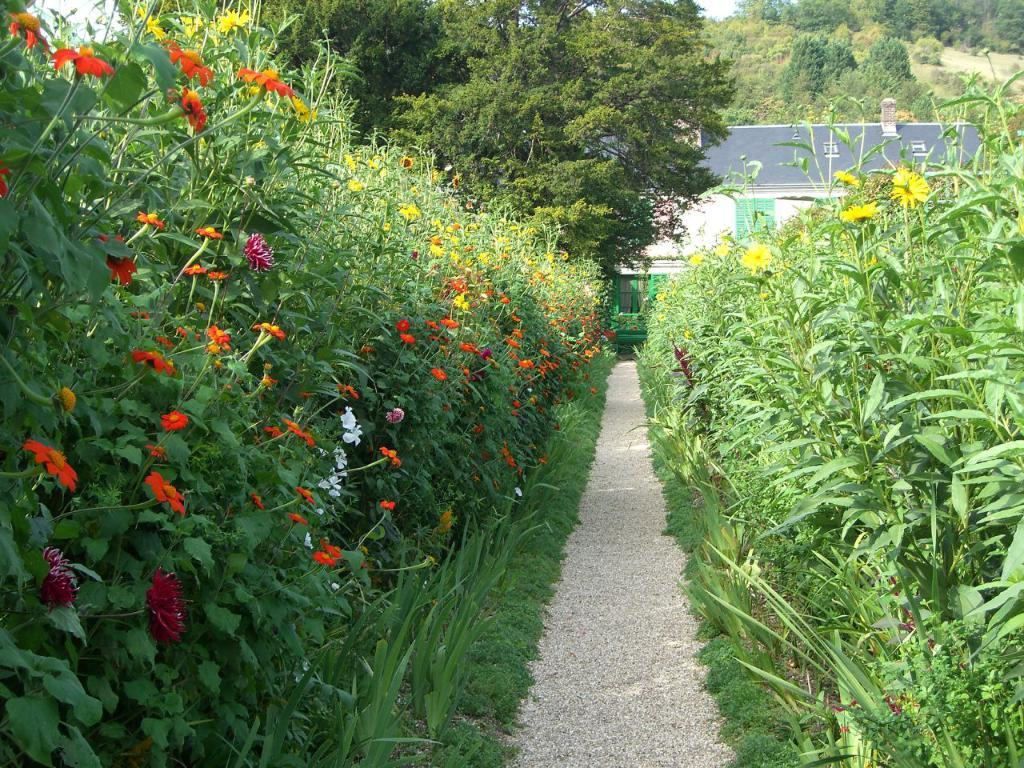What type of vegetation can be seen in the image? There are flowers, plants, trees, and grass in the image. Can you describe the different types of vegetation present? The image contains flowers, plants, trees, and grass. What is the natural environment depicted in the image? The image shows a variety of vegetation, including flowers, plants, trees, and grass. What color is the actor wearing in the image? There is no actor present in the image; it features vegetation such as flowers, plants, trees, and grass. 